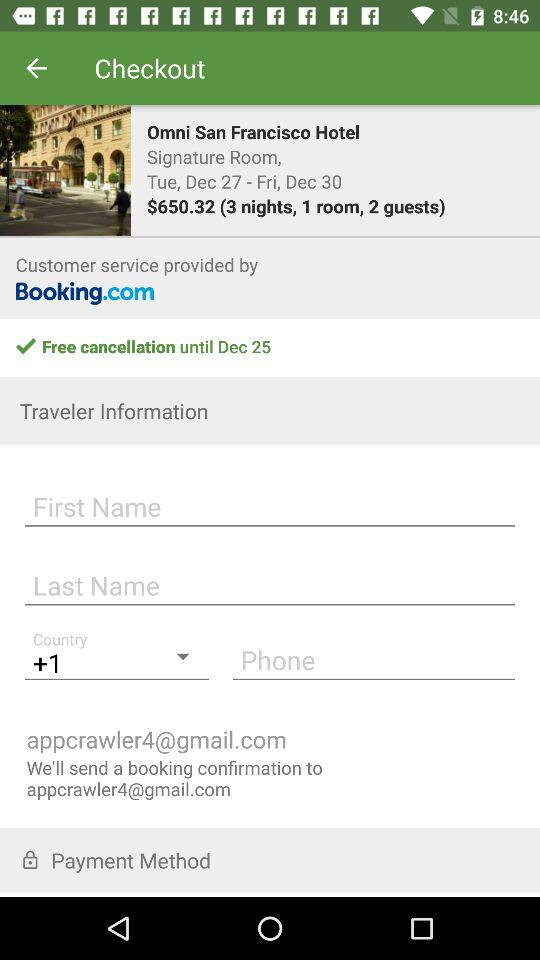What is the chargeable amount? The chargeable amount is $650.32. 